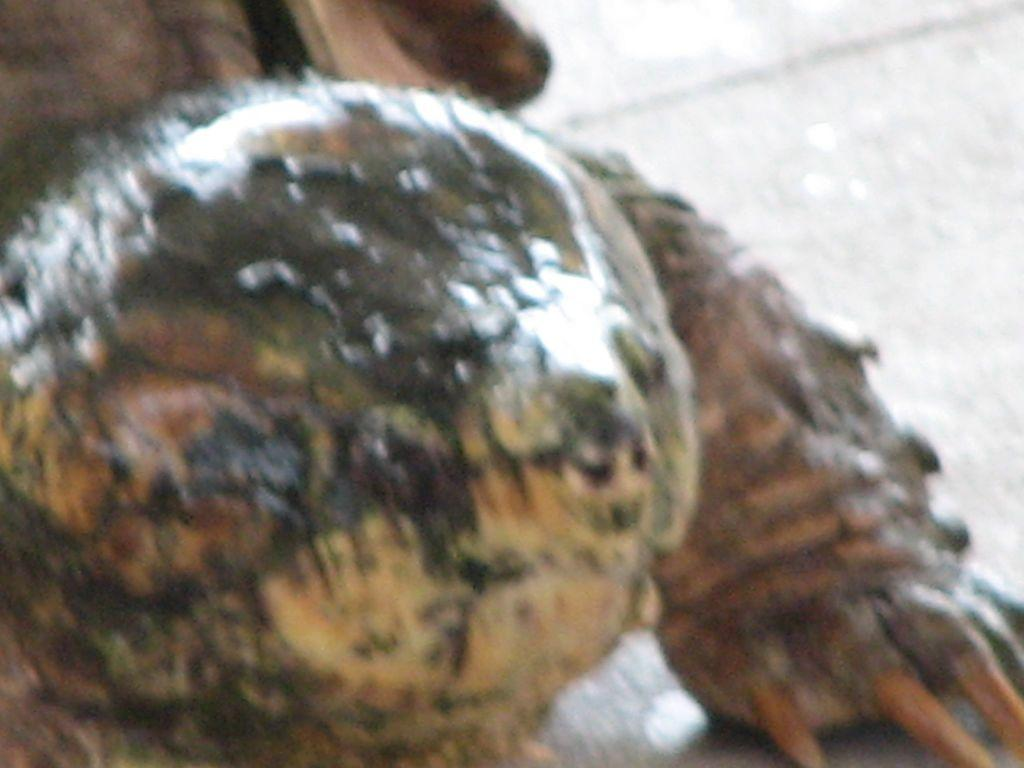What type of living creature is present in the image? There is an animal in the image. Can you describe the background of the image? The background of the image is blurred. What type of gun is being held by the animal in the image? There is no gun present in the image; it only features an animal and a blurred background. 